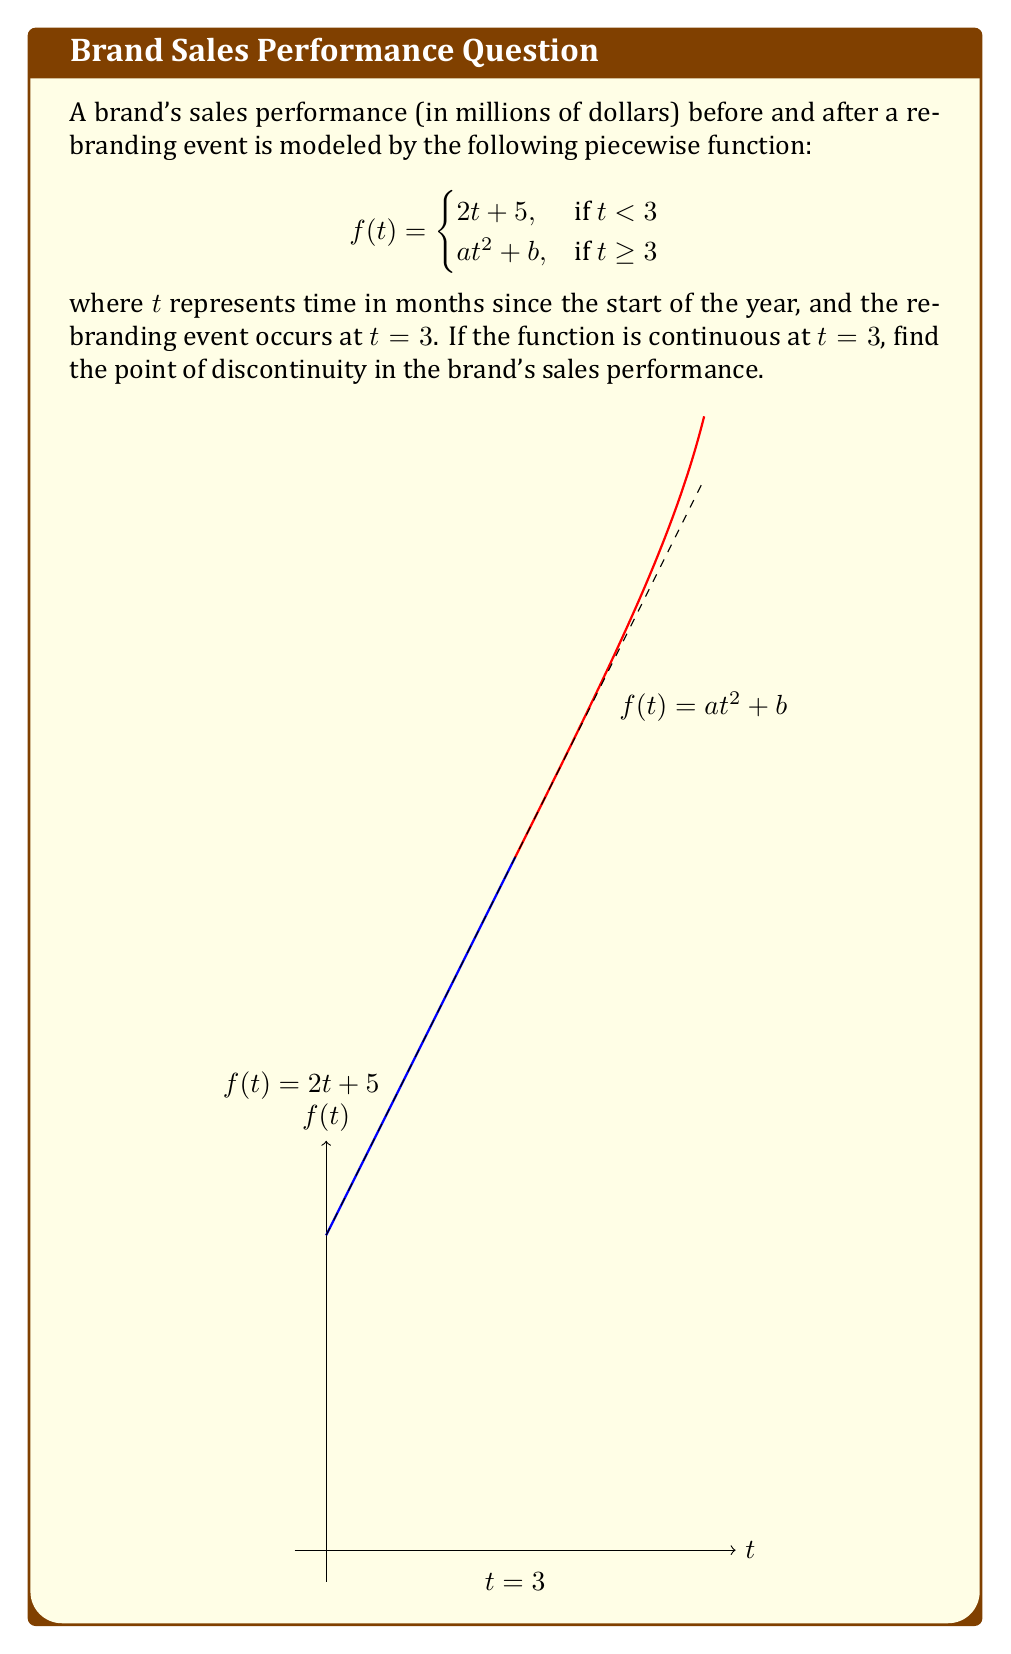Can you solve this math problem? Let's approach this step-by-step:

1) For the function to be continuous at $t = 3$, the limit of $f(t)$ as $t$ approaches 3 from both sides must exist and be equal to $f(3)$. This means:

   $$\lim_{t \to 3^-} f(t) = \lim_{t \to 3^+} f(t) = f(3)$$

2) From the left side:
   $$\lim_{t \to 3^-} f(t) = \lim_{t \to 3^-} (2t + 5) = 2(3) + 5 = 11$$

3) From the right side:
   $$\lim_{t \to 3^+} f(t) = \lim_{t \to 3^+} (at^2 + b) = 9a + b$$

4) For continuity, these must be equal:
   $$11 = 9a + b$$

5) We're also told that the function is continuous at $t = 3$, which means:
   $$f(3) = 2(3) + 5 = 11 = 9a + b$$

6) This confirms that the function is indeed continuous at $t = 3$.

7) Since the function is continuous at the point of rebranding ($t = 3$), and it's defined by a piecewise function with no other transition points, there are no points of discontinuity in the brand's sales performance.
Answer: No point of discontinuity exists. 